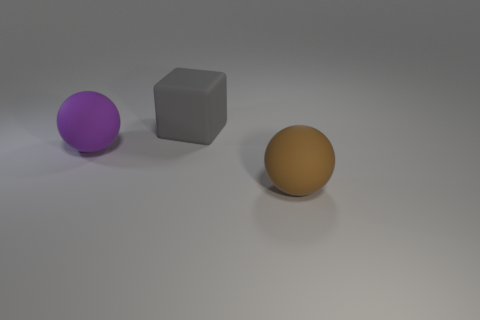Do the brown thing and the rubber block have the same size?
Provide a succinct answer. Yes. Is there anything else that is the same shape as the brown thing?
Give a very brief answer. Yes. Are the purple thing and the sphere right of the gray rubber thing made of the same material?
Your response must be concise. Yes. Do the ball in front of the purple sphere and the large cube have the same color?
Make the answer very short. No. How many large things are both in front of the gray object and on the left side of the brown ball?
Your answer should be very brief. 1. Are the big purple ball that is to the left of the block and the gray cube made of the same material?
Your answer should be compact. Yes. There is a ball left of the matte object right of the matte object that is behind the purple matte object; what is its size?
Ensure brevity in your answer.  Large. What number of other objects are there of the same color as the large block?
Your response must be concise. 0. What is the shape of the brown rubber object that is the same size as the gray rubber object?
Provide a succinct answer. Sphere. There is a rubber object left of the gray matte block; what is its size?
Your answer should be compact. Large. 